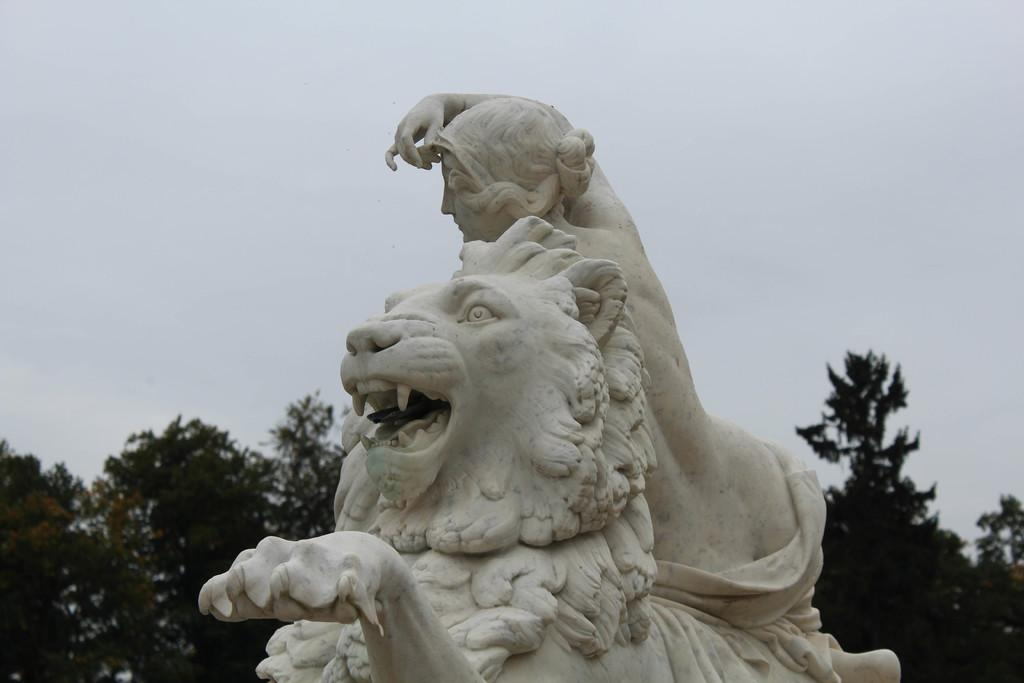Where was the picture taken? The picture was clicked outside. What is the main subject of the image? There is a sculpture of a lion and a sculpture of a person in the center of the image. What can be seen in the background of the image? The sky and trees are visible in the background of the image. What type of tools does the carpenter use in the image? There is no carpenter present in the image. How does the lock on the sculpture work in the image? There is no lock present on the sculptures in the image. 